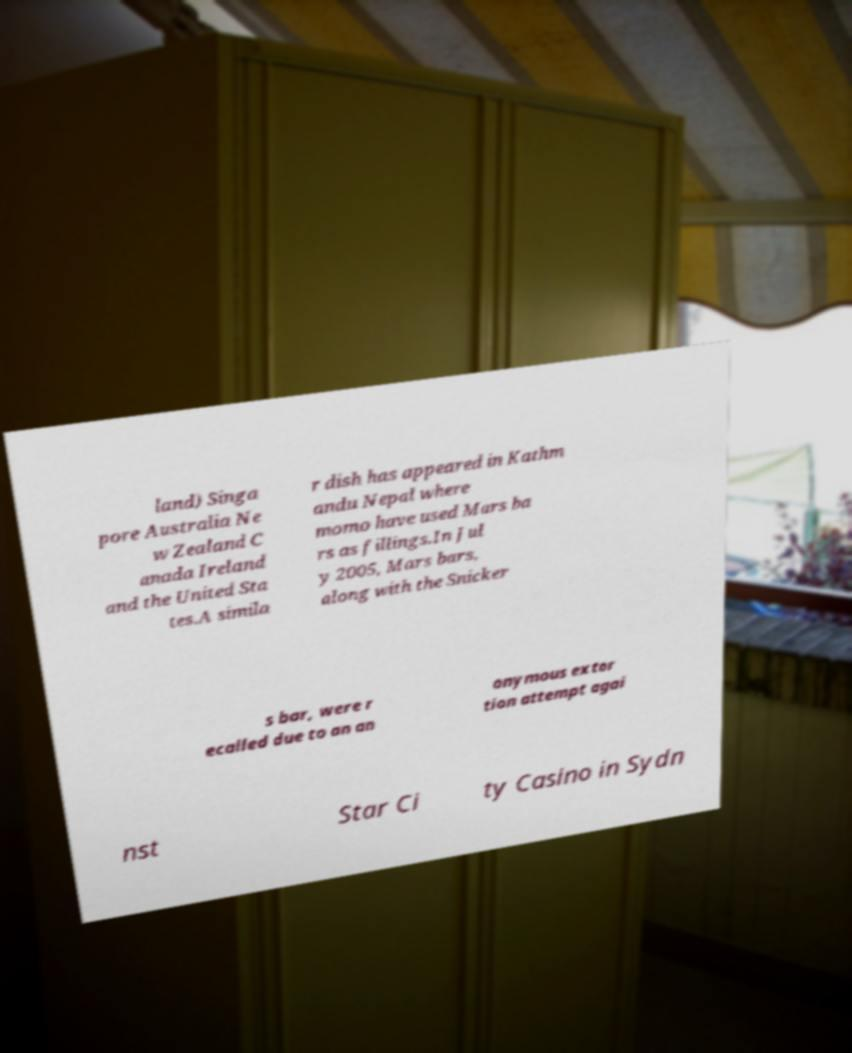What messages or text are displayed in this image? I need them in a readable, typed format. land) Singa pore Australia Ne w Zealand C anada Ireland and the United Sta tes.A simila r dish has appeared in Kathm andu Nepal where momo have used Mars ba rs as fillings.In Jul y 2005, Mars bars, along with the Snicker s bar, were r ecalled due to an an onymous extor tion attempt agai nst Star Ci ty Casino in Sydn 